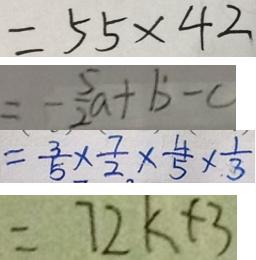<formula> <loc_0><loc_0><loc_500><loc_500>= 5 5 \times 4 2 
 = - \frac { 5 } { 2 } a + b - c 
 = \frac { 3 } { 5 } \times \frac { 7 } { 2 } \times \frac { 4 } { 5 } \times \frac { 1 } { 3 } 
 = 7 2 k + 3</formula> 